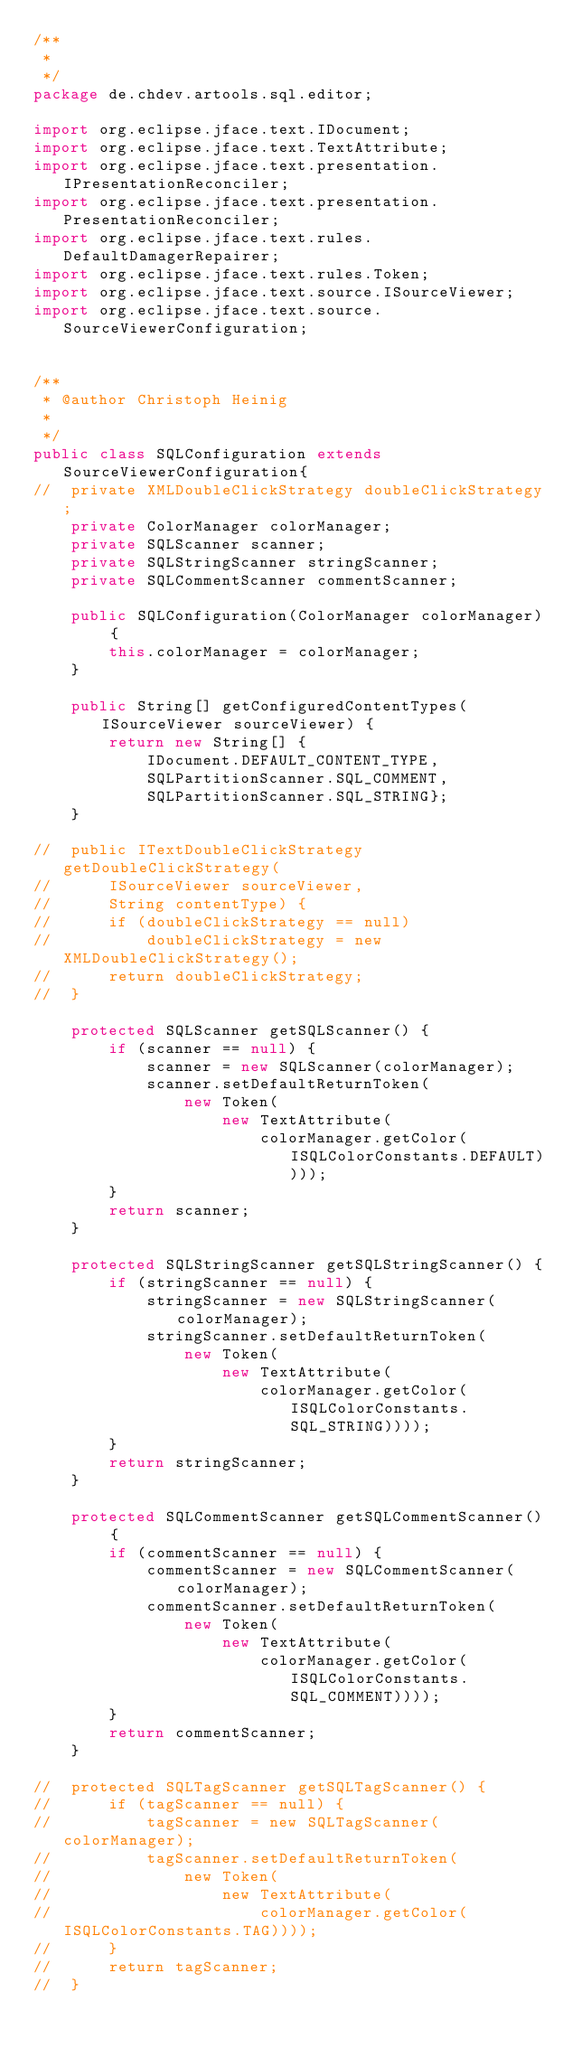<code> <loc_0><loc_0><loc_500><loc_500><_Java_>/**
 * 
 */
package de.chdev.artools.sql.editor;

import org.eclipse.jface.text.IDocument;
import org.eclipse.jface.text.TextAttribute;
import org.eclipse.jface.text.presentation.IPresentationReconciler;
import org.eclipse.jface.text.presentation.PresentationReconciler;
import org.eclipse.jface.text.rules.DefaultDamagerRepairer;
import org.eclipse.jface.text.rules.Token;
import org.eclipse.jface.text.source.ISourceViewer;
import org.eclipse.jface.text.source.SourceViewerConfiguration;


/**
 * @author Christoph Heinig
 *
 */
public class SQLConfiguration extends SourceViewerConfiguration{
//	private XMLDoubleClickStrategy doubleClickStrategy;
	private ColorManager colorManager;
	private SQLScanner scanner;
	private SQLStringScanner stringScanner;
	private SQLCommentScanner commentScanner;

	public SQLConfiguration(ColorManager colorManager) {
		this.colorManager = colorManager;
	}
	
	public String[] getConfiguredContentTypes(ISourceViewer sourceViewer) {
		return new String[] {
			IDocument.DEFAULT_CONTENT_TYPE,
			SQLPartitionScanner.SQL_COMMENT,
			SQLPartitionScanner.SQL_STRING};
	}
	
//	public ITextDoubleClickStrategy getDoubleClickStrategy(
//		ISourceViewer sourceViewer,
//		String contentType) {
//		if (doubleClickStrategy == null)
//			doubleClickStrategy = new XMLDoubleClickStrategy();
//		return doubleClickStrategy;
//	}

	protected SQLScanner getSQLScanner() {
		if (scanner == null) {
			scanner = new SQLScanner(colorManager);
			scanner.setDefaultReturnToken(
				new Token(
					new TextAttribute(
						colorManager.getColor(ISQLColorConstants.DEFAULT))));
		}
		return scanner;
	}

	protected SQLStringScanner getSQLStringScanner() {
		if (stringScanner == null) {
			stringScanner = new SQLStringScanner(colorManager);
			stringScanner.setDefaultReturnToken(
				new Token(
					new TextAttribute(
						colorManager.getColor(ISQLColorConstants.SQL_STRING))));
		}
		return stringScanner;
	}

	protected SQLCommentScanner getSQLCommentScanner() {
		if (commentScanner == null) {
			commentScanner = new SQLCommentScanner(colorManager);
			commentScanner.setDefaultReturnToken(
				new Token(
					new TextAttribute(
						colorManager.getColor(ISQLColorConstants.SQL_COMMENT))));
		}
		return commentScanner;
	}
	
//	protected SQLTagScanner getSQLTagScanner() {
//		if (tagScanner == null) {
//			tagScanner = new SQLTagScanner(colorManager);
//			tagScanner.setDefaultReturnToken(
//				new Token(
//					new TextAttribute(
//						colorManager.getColor(ISQLColorConstants.TAG))));
//		}
//		return tagScanner;
//	}
</code> 